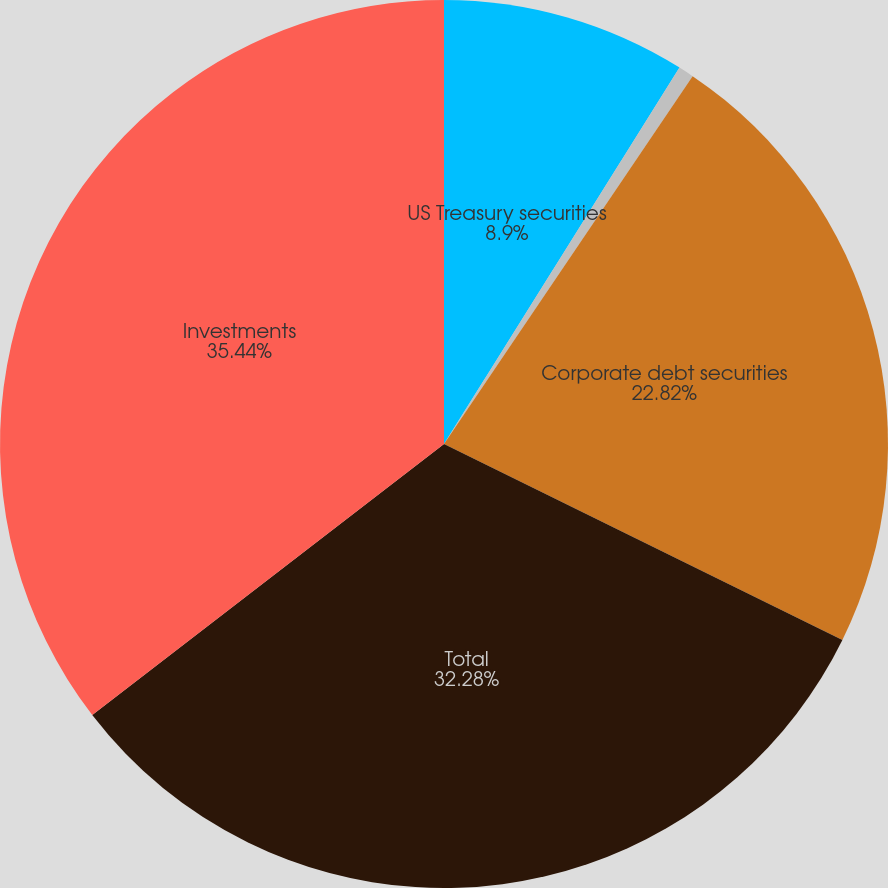<chart> <loc_0><loc_0><loc_500><loc_500><pie_chart><fcel>US Treasury securities<fcel>Foreign government securities<fcel>Corporate debt securities<fcel>Total<fcel>Investments<nl><fcel>8.9%<fcel>0.56%<fcel>22.82%<fcel>32.28%<fcel>35.45%<nl></chart> 